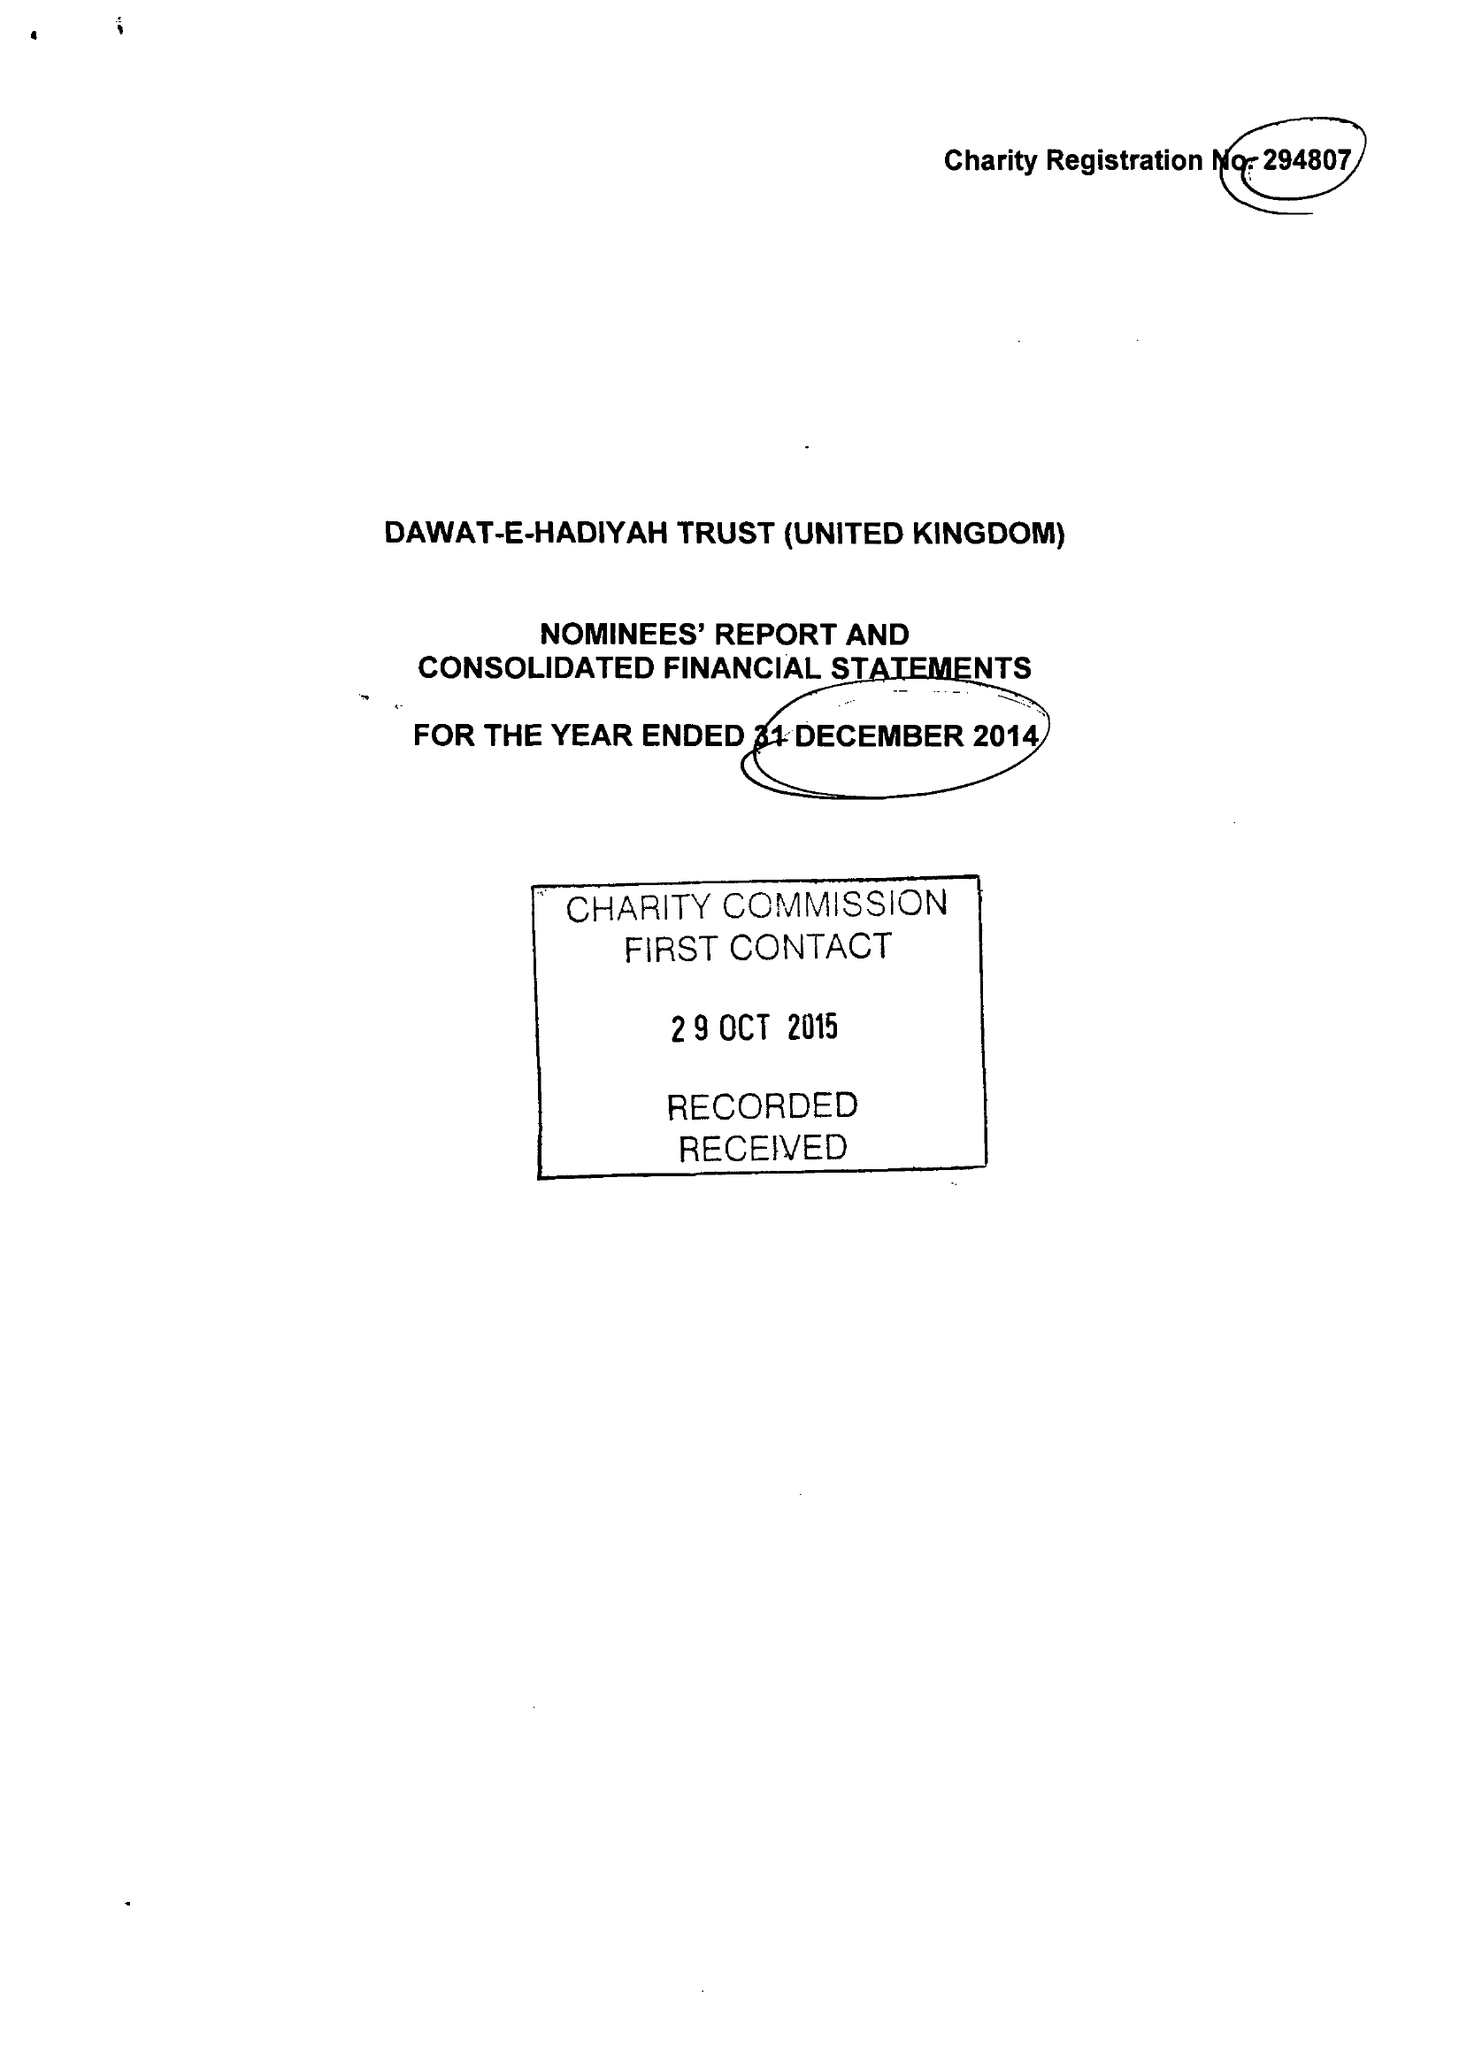What is the value for the report_date?
Answer the question using a single word or phrase. 2014-12-31 